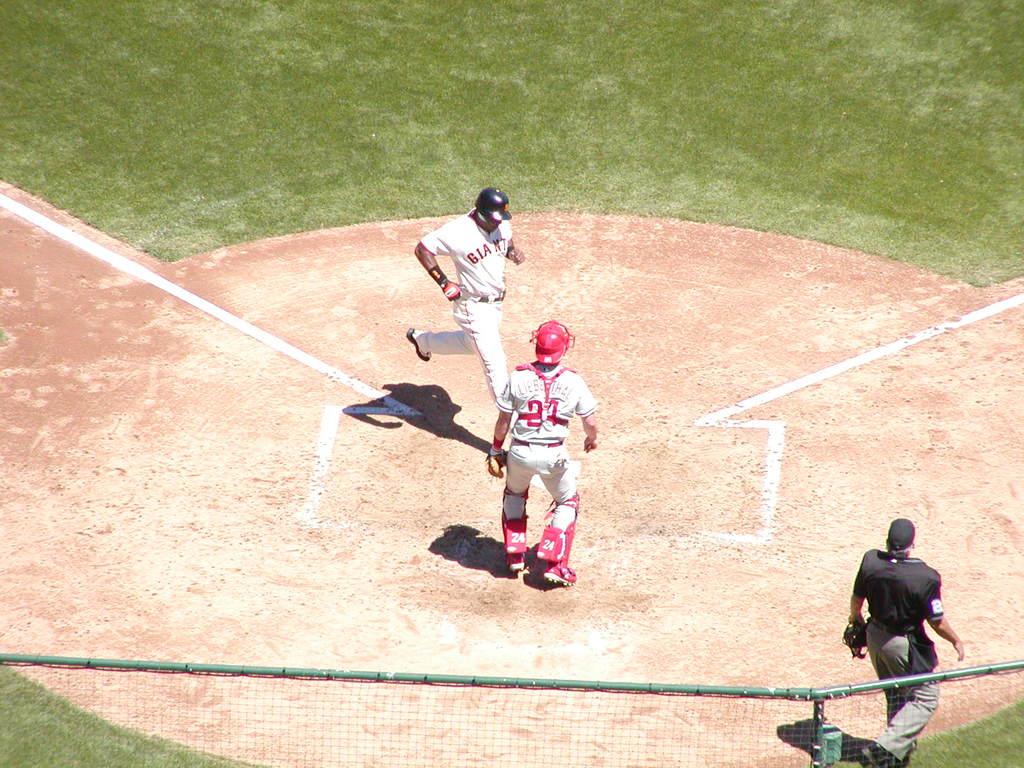What team does the man crossing home plate play for?
Your response must be concise. Giants. What is the umpires number?
Your answer should be very brief. 2. 